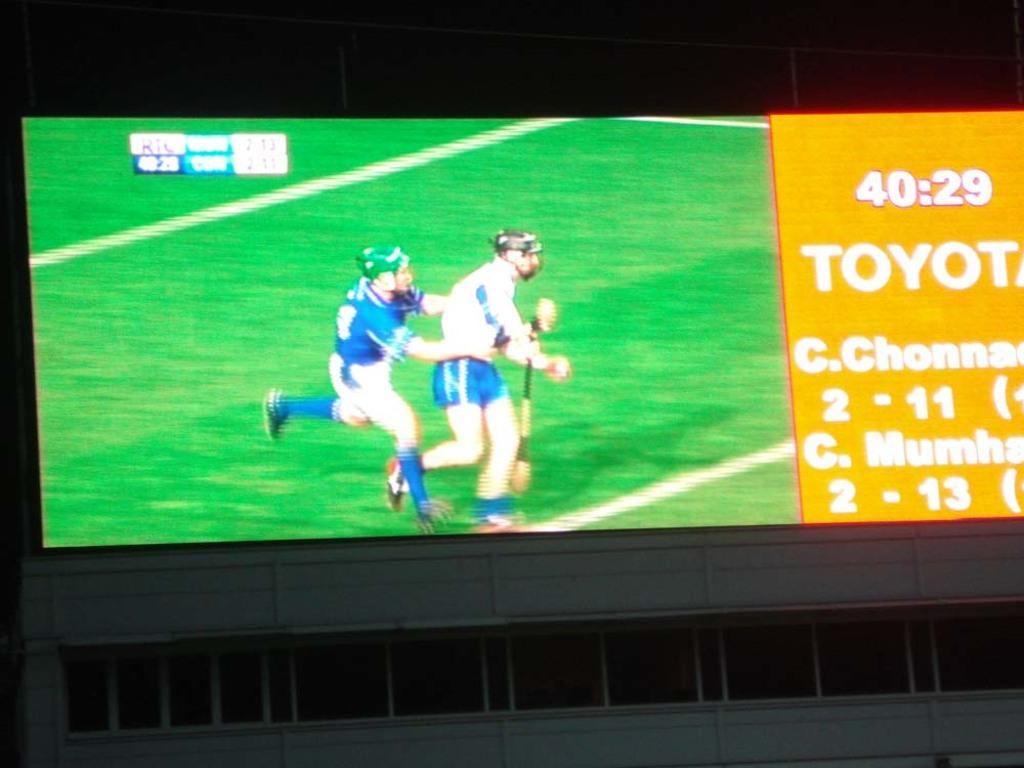Provide a one-sentence caption for the provided image. two men playing cricket and the time is 40:29 and Toyota is displayed. 